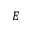Convert formula to latex. <formula><loc_0><loc_0><loc_500><loc_500>E</formula> 